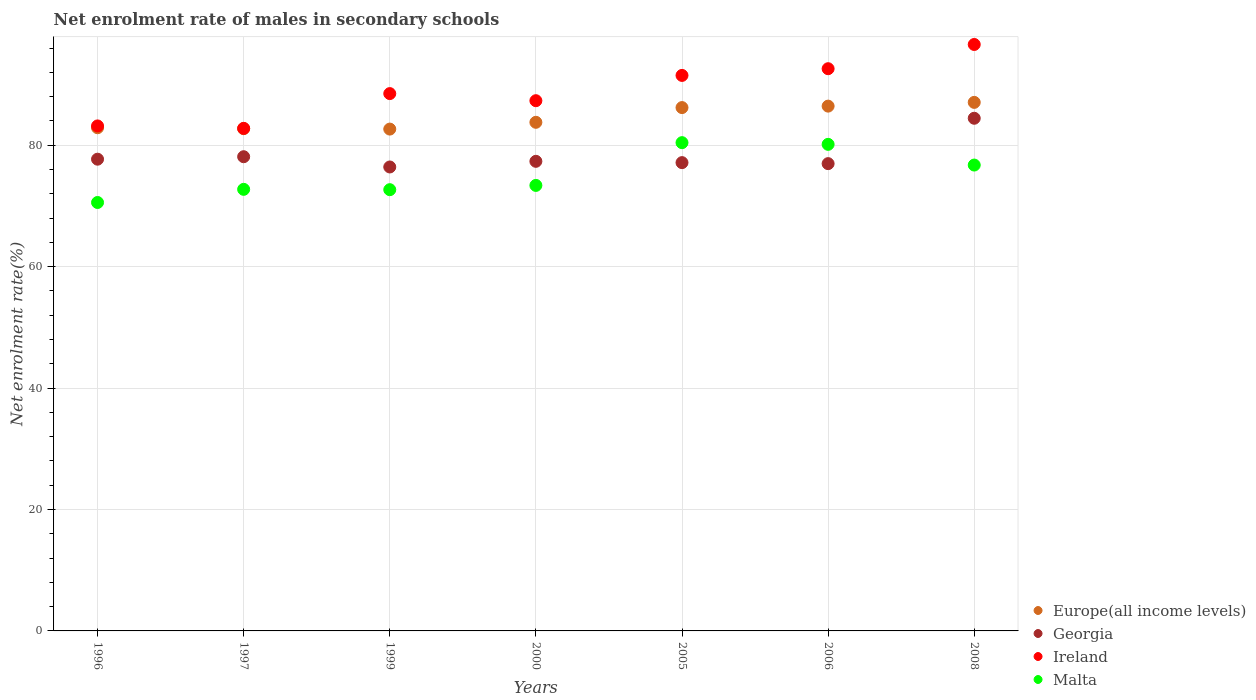Is the number of dotlines equal to the number of legend labels?
Offer a terse response. Yes. What is the net enrolment rate of males in secondary schools in Malta in 2008?
Your answer should be compact. 76.73. Across all years, what is the maximum net enrolment rate of males in secondary schools in Malta?
Provide a succinct answer. 80.41. Across all years, what is the minimum net enrolment rate of males in secondary schools in Europe(all income levels)?
Provide a short and direct response. 82.65. In which year was the net enrolment rate of males in secondary schools in Malta minimum?
Give a very brief answer. 1996. What is the total net enrolment rate of males in secondary schools in Georgia in the graph?
Keep it short and to the point. 548.06. What is the difference between the net enrolment rate of males in secondary schools in Europe(all income levels) in 2005 and that in 2008?
Keep it short and to the point. -0.86. What is the difference between the net enrolment rate of males in secondary schools in Ireland in 1996 and the net enrolment rate of males in secondary schools in Malta in 2008?
Give a very brief answer. 6.44. What is the average net enrolment rate of males in secondary schools in Europe(all income levels) per year?
Provide a succinct answer. 84.53. In the year 1999, what is the difference between the net enrolment rate of males in secondary schools in Ireland and net enrolment rate of males in secondary schools in Malta?
Provide a short and direct response. 15.82. What is the ratio of the net enrolment rate of males in secondary schools in Malta in 1997 to that in 2000?
Keep it short and to the point. 0.99. What is the difference between the highest and the second highest net enrolment rate of males in secondary schools in Ireland?
Your answer should be compact. 3.99. What is the difference between the highest and the lowest net enrolment rate of males in secondary schools in Malta?
Provide a succinct answer. 9.85. In how many years, is the net enrolment rate of males in secondary schools in Malta greater than the average net enrolment rate of males in secondary schools in Malta taken over all years?
Provide a short and direct response. 3. Is the sum of the net enrolment rate of males in secondary schools in Ireland in 1996 and 2008 greater than the maximum net enrolment rate of males in secondary schools in Europe(all income levels) across all years?
Give a very brief answer. Yes. Is it the case that in every year, the sum of the net enrolment rate of males in secondary schools in Georgia and net enrolment rate of males in secondary schools in Ireland  is greater than the sum of net enrolment rate of males in secondary schools in Europe(all income levels) and net enrolment rate of males in secondary schools in Malta?
Make the answer very short. Yes. Does the net enrolment rate of males in secondary schools in Georgia monotonically increase over the years?
Give a very brief answer. No. Is the net enrolment rate of males in secondary schools in Georgia strictly greater than the net enrolment rate of males in secondary schools in Ireland over the years?
Provide a succinct answer. No. Is the net enrolment rate of males in secondary schools in Georgia strictly less than the net enrolment rate of males in secondary schools in Malta over the years?
Your answer should be compact. No. Does the graph contain any zero values?
Your answer should be very brief. No. Where does the legend appear in the graph?
Provide a succinct answer. Bottom right. How are the legend labels stacked?
Provide a short and direct response. Vertical. What is the title of the graph?
Give a very brief answer. Net enrolment rate of males in secondary schools. Does "High income: OECD" appear as one of the legend labels in the graph?
Provide a succinct answer. No. What is the label or title of the X-axis?
Give a very brief answer. Years. What is the label or title of the Y-axis?
Provide a short and direct response. Net enrolment rate(%). What is the Net enrolment rate(%) of Europe(all income levels) in 1996?
Make the answer very short. 82.87. What is the Net enrolment rate(%) in Georgia in 1996?
Make the answer very short. 77.69. What is the Net enrolment rate(%) of Ireland in 1996?
Give a very brief answer. 83.17. What is the Net enrolment rate(%) of Malta in 1996?
Your answer should be compact. 70.56. What is the Net enrolment rate(%) of Europe(all income levels) in 1997?
Provide a short and direct response. 82.72. What is the Net enrolment rate(%) in Georgia in 1997?
Offer a terse response. 78.1. What is the Net enrolment rate(%) of Ireland in 1997?
Provide a succinct answer. 82.77. What is the Net enrolment rate(%) of Malta in 1997?
Your answer should be very brief. 72.73. What is the Net enrolment rate(%) in Europe(all income levels) in 1999?
Your answer should be very brief. 82.65. What is the Net enrolment rate(%) of Georgia in 1999?
Provide a succinct answer. 76.41. What is the Net enrolment rate(%) of Ireland in 1999?
Offer a terse response. 88.5. What is the Net enrolment rate(%) in Malta in 1999?
Offer a very short reply. 72.67. What is the Net enrolment rate(%) in Europe(all income levels) in 2000?
Offer a terse response. 83.77. What is the Net enrolment rate(%) in Georgia in 2000?
Make the answer very short. 77.34. What is the Net enrolment rate(%) in Ireland in 2000?
Provide a succinct answer. 87.33. What is the Net enrolment rate(%) of Malta in 2000?
Keep it short and to the point. 73.37. What is the Net enrolment rate(%) of Europe(all income levels) in 2005?
Keep it short and to the point. 86.19. What is the Net enrolment rate(%) in Georgia in 2005?
Your response must be concise. 77.13. What is the Net enrolment rate(%) in Ireland in 2005?
Offer a very short reply. 91.49. What is the Net enrolment rate(%) in Malta in 2005?
Give a very brief answer. 80.41. What is the Net enrolment rate(%) in Europe(all income levels) in 2006?
Keep it short and to the point. 86.43. What is the Net enrolment rate(%) of Georgia in 2006?
Keep it short and to the point. 76.96. What is the Net enrolment rate(%) of Ireland in 2006?
Ensure brevity in your answer.  92.59. What is the Net enrolment rate(%) of Malta in 2006?
Your answer should be compact. 80.14. What is the Net enrolment rate(%) in Europe(all income levels) in 2008?
Keep it short and to the point. 87.05. What is the Net enrolment rate(%) of Georgia in 2008?
Your answer should be compact. 84.43. What is the Net enrolment rate(%) in Ireland in 2008?
Make the answer very short. 96.59. What is the Net enrolment rate(%) in Malta in 2008?
Provide a succinct answer. 76.73. Across all years, what is the maximum Net enrolment rate(%) of Europe(all income levels)?
Ensure brevity in your answer.  87.05. Across all years, what is the maximum Net enrolment rate(%) in Georgia?
Your answer should be very brief. 84.43. Across all years, what is the maximum Net enrolment rate(%) in Ireland?
Ensure brevity in your answer.  96.59. Across all years, what is the maximum Net enrolment rate(%) in Malta?
Your answer should be compact. 80.41. Across all years, what is the minimum Net enrolment rate(%) of Europe(all income levels)?
Ensure brevity in your answer.  82.65. Across all years, what is the minimum Net enrolment rate(%) of Georgia?
Make the answer very short. 76.41. Across all years, what is the minimum Net enrolment rate(%) of Ireland?
Offer a terse response. 82.77. Across all years, what is the minimum Net enrolment rate(%) of Malta?
Your response must be concise. 70.56. What is the total Net enrolment rate(%) of Europe(all income levels) in the graph?
Give a very brief answer. 591.68. What is the total Net enrolment rate(%) in Georgia in the graph?
Make the answer very short. 548.06. What is the total Net enrolment rate(%) of Ireland in the graph?
Your answer should be very brief. 622.43. What is the total Net enrolment rate(%) of Malta in the graph?
Your response must be concise. 526.61. What is the difference between the Net enrolment rate(%) of Europe(all income levels) in 1996 and that in 1997?
Offer a terse response. 0.15. What is the difference between the Net enrolment rate(%) of Georgia in 1996 and that in 1997?
Your answer should be very brief. -0.41. What is the difference between the Net enrolment rate(%) of Ireland in 1996 and that in 1997?
Offer a terse response. 0.4. What is the difference between the Net enrolment rate(%) of Malta in 1996 and that in 1997?
Your answer should be very brief. -2.17. What is the difference between the Net enrolment rate(%) in Europe(all income levels) in 1996 and that in 1999?
Your answer should be very brief. 0.22. What is the difference between the Net enrolment rate(%) in Georgia in 1996 and that in 1999?
Offer a very short reply. 1.28. What is the difference between the Net enrolment rate(%) in Ireland in 1996 and that in 1999?
Make the answer very short. -5.33. What is the difference between the Net enrolment rate(%) of Malta in 1996 and that in 1999?
Make the answer very short. -2.11. What is the difference between the Net enrolment rate(%) of Europe(all income levels) in 1996 and that in 2000?
Your response must be concise. -0.9. What is the difference between the Net enrolment rate(%) of Georgia in 1996 and that in 2000?
Keep it short and to the point. 0.35. What is the difference between the Net enrolment rate(%) in Ireland in 1996 and that in 2000?
Provide a succinct answer. -4.16. What is the difference between the Net enrolment rate(%) in Malta in 1996 and that in 2000?
Give a very brief answer. -2.81. What is the difference between the Net enrolment rate(%) in Europe(all income levels) in 1996 and that in 2005?
Your answer should be compact. -3.32. What is the difference between the Net enrolment rate(%) in Georgia in 1996 and that in 2005?
Your answer should be very brief. 0.57. What is the difference between the Net enrolment rate(%) of Ireland in 1996 and that in 2005?
Offer a terse response. -8.32. What is the difference between the Net enrolment rate(%) in Malta in 1996 and that in 2005?
Make the answer very short. -9.85. What is the difference between the Net enrolment rate(%) in Europe(all income levels) in 1996 and that in 2006?
Provide a short and direct response. -3.56. What is the difference between the Net enrolment rate(%) of Georgia in 1996 and that in 2006?
Keep it short and to the point. 0.73. What is the difference between the Net enrolment rate(%) in Ireland in 1996 and that in 2006?
Offer a very short reply. -9.42. What is the difference between the Net enrolment rate(%) in Malta in 1996 and that in 2006?
Ensure brevity in your answer.  -9.58. What is the difference between the Net enrolment rate(%) of Europe(all income levels) in 1996 and that in 2008?
Your response must be concise. -4.18. What is the difference between the Net enrolment rate(%) of Georgia in 1996 and that in 2008?
Keep it short and to the point. -6.74. What is the difference between the Net enrolment rate(%) in Ireland in 1996 and that in 2008?
Your answer should be very brief. -13.42. What is the difference between the Net enrolment rate(%) of Malta in 1996 and that in 2008?
Keep it short and to the point. -6.17. What is the difference between the Net enrolment rate(%) of Europe(all income levels) in 1997 and that in 1999?
Give a very brief answer. 0.07. What is the difference between the Net enrolment rate(%) in Georgia in 1997 and that in 1999?
Your answer should be very brief. 1.69. What is the difference between the Net enrolment rate(%) of Ireland in 1997 and that in 1999?
Offer a terse response. -5.72. What is the difference between the Net enrolment rate(%) in Malta in 1997 and that in 1999?
Keep it short and to the point. 0.06. What is the difference between the Net enrolment rate(%) of Europe(all income levels) in 1997 and that in 2000?
Ensure brevity in your answer.  -1.05. What is the difference between the Net enrolment rate(%) of Georgia in 1997 and that in 2000?
Make the answer very short. 0.76. What is the difference between the Net enrolment rate(%) of Ireland in 1997 and that in 2000?
Ensure brevity in your answer.  -4.56. What is the difference between the Net enrolment rate(%) in Malta in 1997 and that in 2000?
Your response must be concise. -0.65. What is the difference between the Net enrolment rate(%) of Europe(all income levels) in 1997 and that in 2005?
Ensure brevity in your answer.  -3.47. What is the difference between the Net enrolment rate(%) of Georgia in 1997 and that in 2005?
Provide a succinct answer. 0.97. What is the difference between the Net enrolment rate(%) of Ireland in 1997 and that in 2005?
Provide a short and direct response. -8.72. What is the difference between the Net enrolment rate(%) of Malta in 1997 and that in 2005?
Your answer should be very brief. -7.69. What is the difference between the Net enrolment rate(%) in Europe(all income levels) in 1997 and that in 2006?
Offer a very short reply. -3.71. What is the difference between the Net enrolment rate(%) in Georgia in 1997 and that in 2006?
Provide a short and direct response. 1.14. What is the difference between the Net enrolment rate(%) in Ireland in 1997 and that in 2006?
Keep it short and to the point. -9.82. What is the difference between the Net enrolment rate(%) in Malta in 1997 and that in 2006?
Provide a short and direct response. -7.41. What is the difference between the Net enrolment rate(%) of Europe(all income levels) in 1997 and that in 2008?
Make the answer very short. -4.33. What is the difference between the Net enrolment rate(%) in Georgia in 1997 and that in 2008?
Your response must be concise. -6.33. What is the difference between the Net enrolment rate(%) of Ireland in 1997 and that in 2008?
Offer a terse response. -13.81. What is the difference between the Net enrolment rate(%) in Malta in 1997 and that in 2008?
Ensure brevity in your answer.  -4. What is the difference between the Net enrolment rate(%) in Europe(all income levels) in 1999 and that in 2000?
Offer a terse response. -1.12. What is the difference between the Net enrolment rate(%) of Georgia in 1999 and that in 2000?
Provide a short and direct response. -0.93. What is the difference between the Net enrolment rate(%) of Ireland in 1999 and that in 2000?
Give a very brief answer. 1.17. What is the difference between the Net enrolment rate(%) in Malta in 1999 and that in 2000?
Your response must be concise. -0.7. What is the difference between the Net enrolment rate(%) in Europe(all income levels) in 1999 and that in 2005?
Provide a succinct answer. -3.54. What is the difference between the Net enrolment rate(%) of Georgia in 1999 and that in 2005?
Provide a short and direct response. -0.72. What is the difference between the Net enrolment rate(%) of Ireland in 1999 and that in 2005?
Your response must be concise. -2.99. What is the difference between the Net enrolment rate(%) of Malta in 1999 and that in 2005?
Keep it short and to the point. -7.74. What is the difference between the Net enrolment rate(%) of Europe(all income levels) in 1999 and that in 2006?
Give a very brief answer. -3.78. What is the difference between the Net enrolment rate(%) of Georgia in 1999 and that in 2006?
Offer a very short reply. -0.55. What is the difference between the Net enrolment rate(%) of Ireland in 1999 and that in 2006?
Make the answer very short. -4.1. What is the difference between the Net enrolment rate(%) of Malta in 1999 and that in 2006?
Make the answer very short. -7.47. What is the difference between the Net enrolment rate(%) of Europe(all income levels) in 1999 and that in 2008?
Offer a terse response. -4.4. What is the difference between the Net enrolment rate(%) in Georgia in 1999 and that in 2008?
Provide a short and direct response. -8.02. What is the difference between the Net enrolment rate(%) in Ireland in 1999 and that in 2008?
Your answer should be compact. -8.09. What is the difference between the Net enrolment rate(%) of Malta in 1999 and that in 2008?
Keep it short and to the point. -4.06. What is the difference between the Net enrolment rate(%) of Europe(all income levels) in 2000 and that in 2005?
Give a very brief answer. -2.42. What is the difference between the Net enrolment rate(%) in Georgia in 2000 and that in 2005?
Provide a short and direct response. 0.22. What is the difference between the Net enrolment rate(%) of Ireland in 2000 and that in 2005?
Offer a very short reply. -4.16. What is the difference between the Net enrolment rate(%) in Malta in 2000 and that in 2005?
Make the answer very short. -7.04. What is the difference between the Net enrolment rate(%) of Europe(all income levels) in 2000 and that in 2006?
Give a very brief answer. -2.67. What is the difference between the Net enrolment rate(%) of Georgia in 2000 and that in 2006?
Make the answer very short. 0.38. What is the difference between the Net enrolment rate(%) in Ireland in 2000 and that in 2006?
Give a very brief answer. -5.27. What is the difference between the Net enrolment rate(%) in Malta in 2000 and that in 2006?
Offer a terse response. -6.76. What is the difference between the Net enrolment rate(%) of Europe(all income levels) in 2000 and that in 2008?
Your response must be concise. -3.28. What is the difference between the Net enrolment rate(%) in Georgia in 2000 and that in 2008?
Ensure brevity in your answer.  -7.09. What is the difference between the Net enrolment rate(%) in Ireland in 2000 and that in 2008?
Offer a very short reply. -9.26. What is the difference between the Net enrolment rate(%) in Malta in 2000 and that in 2008?
Offer a terse response. -3.35. What is the difference between the Net enrolment rate(%) in Europe(all income levels) in 2005 and that in 2006?
Your response must be concise. -0.24. What is the difference between the Net enrolment rate(%) in Georgia in 2005 and that in 2006?
Offer a very short reply. 0.17. What is the difference between the Net enrolment rate(%) of Ireland in 2005 and that in 2006?
Provide a short and direct response. -1.11. What is the difference between the Net enrolment rate(%) in Malta in 2005 and that in 2006?
Give a very brief answer. 0.28. What is the difference between the Net enrolment rate(%) of Europe(all income levels) in 2005 and that in 2008?
Your response must be concise. -0.86. What is the difference between the Net enrolment rate(%) of Georgia in 2005 and that in 2008?
Your answer should be very brief. -7.31. What is the difference between the Net enrolment rate(%) of Ireland in 2005 and that in 2008?
Offer a terse response. -5.1. What is the difference between the Net enrolment rate(%) of Malta in 2005 and that in 2008?
Make the answer very short. 3.69. What is the difference between the Net enrolment rate(%) in Europe(all income levels) in 2006 and that in 2008?
Your answer should be compact. -0.62. What is the difference between the Net enrolment rate(%) of Georgia in 2006 and that in 2008?
Provide a short and direct response. -7.47. What is the difference between the Net enrolment rate(%) of Ireland in 2006 and that in 2008?
Offer a very short reply. -3.99. What is the difference between the Net enrolment rate(%) of Malta in 2006 and that in 2008?
Give a very brief answer. 3.41. What is the difference between the Net enrolment rate(%) of Europe(all income levels) in 1996 and the Net enrolment rate(%) of Georgia in 1997?
Your answer should be compact. 4.77. What is the difference between the Net enrolment rate(%) of Europe(all income levels) in 1996 and the Net enrolment rate(%) of Ireland in 1997?
Ensure brevity in your answer.  0.1. What is the difference between the Net enrolment rate(%) of Europe(all income levels) in 1996 and the Net enrolment rate(%) of Malta in 1997?
Provide a succinct answer. 10.14. What is the difference between the Net enrolment rate(%) of Georgia in 1996 and the Net enrolment rate(%) of Ireland in 1997?
Ensure brevity in your answer.  -5.08. What is the difference between the Net enrolment rate(%) in Georgia in 1996 and the Net enrolment rate(%) in Malta in 1997?
Keep it short and to the point. 4.97. What is the difference between the Net enrolment rate(%) in Ireland in 1996 and the Net enrolment rate(%) in Malta in 1997?
Your answer should be compact. 10.44. What is the difference between the Net enrolment rate(%) of Europe(all income levels) in 1996 and the Net enrolment rate(%) of Georgia in 1999?
Offer a terse response. 6.46. What is the difference between the Net enrolment rate(%) of Europe(all income levels) in 1996 and the Net enrolment rate(%) of Ireland in 1999?
Provide a short and direct response. -5.62. What is the difference between the Net enrolment rate(%) of Europe(all income levels) in 1996 and the Net enrolment rate(%) of Malta in 1999?
Provide a succinct answer. 10.2. What is the difference between the Net enrolment rate(%) of Georgia in 1996 and the Net enrolment rate(%) of Ireland in 1999?
Offer a very short reply. -10.8. What is the difference between the Net enrolment rate(%) of Georgia in 1996 and the Net enrolment rate(%) of Malta in 1999?
Offer a terse response. 5.02. What is the difference between the Net enrolment rate(%) of Ireland in 1996 and the Net enrolment rate(%) of Malta in 1999?
Your answer should be compact. 10.5. What is the difference between the Net enrolment rate(%) in Europe(all income levels) in 1996 and the Net enrolment rate(%) in Georgia in 2000?
Offer a terse response. 5.53. What is the difference between the Net enrolment rate(%) of Europe(all income levels) in 1996 and the Net enrolment rate(%) of Ireland in 2000?
Provide a short and direct response. -4.46. What is the difference between the Net enrolment rate(%) in Europe(all income levels) in 1996 and the Net enrolment rate(%) in Malta in 2000?
Offer a very short reply. 9.5. What is the difference between the Net enrolment rate(%) in Georgia in 1996 and the Net enrolment rate(%) in Ireland in 2000?
Ensure brevity in your answer.  -9.63. What is the difference between the Net enrolment rate(%) in Georgia in 1996 and the Net enrolment rate(%) in Malta in 2000?
Offer a terse response. 4.32. What is the difference between the Net enrolment rate(%) of Ireland in 1996 and the Net enrolment rate(%) of Malta in 2000?
Ensure brevity in your answer.  9.8. What is the difference between the Net enrolment rate(%) in Europe(all income levels) in 1996 and the Net enrolment rate(%) in Georgia in 2005?
Make the answer very short. 5.75. What is the difference between the Net enrolment rate(%) of Europe(all income levels) in 1996 and the Net enrolment rate(%) of Ireland in 2005?
Ensure brevity in your answer.  -8.62. What is the difference between the Net enrolment rate(%) of Europe(all income levels) in 1996 and the Net enrolment rate(%) of Malta in 2005?
Provide a short and direct response. 2.46. What is the difference between the Net enrolment rate(%) in Georgia in 1996 and the Net enrolment rate(%) in Ireland in 2005?
Your response must be concise. -13.8. What is the difference between the Net enrolment rate(%) in Georgia in 1996 and the Net enrolment rate(%) in Malta in 2005?
Your answer should be very brief. -2.72. What is the difference between the Net enrolment rate(%) of Ireland in 1996 and the Net enrolment rate(%) of Malta in 2005?
Make the answer very short. 2.76. What is the difference between the Net enrolment rate(%) in Europe(all income levels) in 1996 and the Net enrolment rate(%) in Georgia in 2006?
Make the answer very short. 5.91. What is the difference between the Net enrolment rate(%) of Europe(all income levels) in 1996 and the Net enrolment rate(%) of Ireland in 2006?
Provide a short and direct response. -9.72. What is the difference between the Net enrolment rate(%) of Europe(all income levels) in 1996 and the Net enrolment rate(%) of Malta in 2006?
Offer a terse response. 2.73. What is the difference between the Net enrolment rate(%) in Georgia in 1996 and the Net enrolment rate(%) in Ireland in 2006?
Provide a short and direct response. -14.9. What is the difference between the Net enrolment rate(%) in Georgia in 1996 and the Net enrolment rate(%) in Malta in 2006?
Give a very brief answer. -2.44. What is the difference between the Net enrolment rate(%) in Ireland in 1996 and the Net enrolment rate(%) in Malta in 2006?
Your answer should be very brief. 3.03. What is the difference between the Net enrolment rate(%) of Europe(all income levels) in 1996 and the Net enrolment rate(%) of Georgia in 2008?
Your response must be concise. -1.56. What is the difference between the Net enrolment rate(%) in Europe(all income levels) in 1996 and the Net enrolment rate(%) in Ireland in 2008?
Offer a very short reply. -13.71. What is the difference between the Net enrolment rate(%) in Europe(all income levels) in 1996 and the Net enrolment rate(%) in Malta in 2008?
Your answer should be compact. 6.14. What is the difference between the Net enrolment rate(%) of Georgia in 1996 and the Net enrolment rate(%) of Ireland in 2008?
Offer a terse response. -18.89. What is the difference between the Net enrolment rate(%) in Georgia in 1996 and the Net enrolment rate(%) in Malta in 2008?
Your answer should be very brief. 0.97. What is the difference between the Net enrolment rate(%) of Ireland in 1996 and the Net enrolment rate(%) of Malta in 2008?
Give a very brief answer. 6.44. What is the difference between the Net enrolment rate(%) of Europe(all income levels) in 1997 and the Net enrolment rate(%) of Georgia in 1999?
Your answer should be compact. 6.31. What is the difference between the Net enrolment rate(%) of Europe(all income levels) in 1997 and the Net enrolment rate(%) of Ireland in 1999?
Your answer should be compact. -5.78. What is the difference between the Net enrolment rate(%) in Europe(all income levels) in 1997 and the Net enrolment rate(%) in Malta in 1999?
Your answer should be compact. 10.05. What is the difference between the Net enrolment rate(%) in Georgia in 1997 and the Net enrolment rate(%) in Ireland in 1999?
Ensure brevity in your answer.  -10.4. What is the difference between the Net enrolment rate(%) of Georgia in 1997 and the Net enrolment rate(%) of Malta in 1999?
Your answer should be compact. 5.43. What is the difference between the Net enrolment rate(%) of Ireland in 1997 and the Net enrolment rate(%) of Malta in 1999?
Make the answer very short. 10.1. What is the difference between the Net enrolment rate(%) of Europe(all income levels) in 1997 and the Net enrolment rate(%) of Georgia in 2000?
Keep it short and to the point. 5.38. What is the difference between the Net enrolment rate(%) in Europe(all income levels) in 1997 and the Net enrolment rate(%) in Ireland in 2000?
Give a very brief answer. -4.61. What is the difference between the Net enrolment rate(%) of Europe(all income levels) in 1997 and the Net enrolment rate(%) of Malta in 2000?
Offer a very short reply. 9.35. What is the difference between the Net enrolment rate(%) in Georgia in 1997 and the Net enrolment rate(%) in Ireland in 2000?
Keep it short and to the point. -9.23. What is the difference between the Net enrolment rate(%) in Georgia in 1997 and the Net enrolment rate(%) in Malta in 2000?
Provide a succinct answer. 4.73. What is the difference between the Net enrolment rate(%) in Ireland in 1997 and the Net enrolment rate(%) in Malta in 2000?
Provide a short and direct response. 9.4. What is the difference between the Net enrolment rate(%) of Europe(all income levels) in 1997 and the Net enrolment rate(%) of Georgia in 2005?
Keep it short and to the point. 5.59. What is the difference between the Net enrolment rate(%) of Europe(all income levels) in 1997 and the Net enrolment rate(%) of Ireland in 2005?
Your response must be concise. -8.77. What is the difference between the Net enrolment rate(%) in Europe(all income levels) in 1997 and the Net enrolment rate(%) in Malta in 2005?
Give a very brief answer. 2.3. What is the difference between the Net enrolment rate(%) in Georgia in 1997 and the Net enrolment rate(%) in Ireland in 2005?
Your answer should be very brief. -13.39. What is the difference between the Net enrolment rate(%) of Georgia in 1997 and the Net enrolment rate(%) of Malta in 2005?
Offer a very short reply. -2.31. What is the difference between the Net enrolment rate(%) of Ireland in 1997 and the Net enrolment rate(%) of Malta in 2005?
Your response must be concise. 2.36. What is the difference between the Net enrolment rate(%) of Europe(all income levels) in 1997 and the Net enrolment rate(%) of Georgia in 2006?
Provide a short and direct response. 5.76. What is the difference between the Net enrolment rate(%) of Europe(all income levels) in 1997 and the Net enrolment rate(%) of Ireland in 2006?
Offer a terse response. -9.88. What is the difference between the Net enrolment rate(%) in Europe(all income levels) in 1997 and the Net enrolment rate(%) in Malta in 2006?
Offer a very short reply. 2.58. What is the difference between the Net enrolment rate(%) in Georgia in 1997 and the Net enrolment rate(%) in Ireland in 2006?
Your answer should be very brief. -14.5. What is the difference between the Net enrolment rate(%) in Georgia in 1997 and the Net enrolment rate(%) in Malta in 2006?
Offer a very short reply. -2.04. What is the difference between the Net enrolment rate(%) of Ireland in 1997 and the Net enrolment rate(%) of Malta in 2006?
Give a very brief answer. 2.63. What is the difference between the Net enrolment rate(%) of Europe(all income levels) in 1997 and the Net enrolment rate(%) of Georgia in 2008?
Provide a succinct answer. -1.71. What is the difference between the Net enrolment rate(%) of Europe(all income levels) in 1997 and the Net enrolment rate(%) of Ireland in 2008?
Keep it short and to the point. -13.87. What is the difference between the Net enrolment rate(%) of Europe(all income levels) in 1997 and the Net enrolment rate(%) of Malta in 2008?
Provide a succinct answer. 5.99. What is the difference between the Net enrolment rate(%) in Georgia in 1997 and the Net enrolment rate(%) in Ireland in 2008?
Provide a succinct answer. -18.49. What is the difference between the Net enrolment rate(%) in Georgia in 1997 and the Net enrolment rate(%) in Malta in 2008?
Provide a short and direct response. 1.37. What is the difference between the Net enrolment rate(%) of Ireland in 1997 and the Net enrolment rate(%) of Malta in 2008?
Your response must be concise. 6.04. What is the difference between the Net enrolment rate(%) in Europe(all income levels) in 1999 and the Net enrolment rate(%) in Georgia in 2000?
Provide a succinct answer. 5.31. What is the difference between the Net enrolment rate(%) in Europe(all income levels) in 1999 and the Net enrolment rate(%) in Ireland in 2000?
Your response must be concise. -4.68. What is the difference between the Net enrolment rate(%) of Europe(all income levels) in 1999 and the Net enrolment rate(%) of Malta in 2000?
Ensure brevity in your answer.  9.28. What is the difference between the Net enrolment rate(%) in Georgia in 1999 and the Net enrolment rate(%) in Ireland in 2000?
Offer a terse response. -10.92. What is the difference between the Net enrolment rate(%) of Georgia in 1999 and the Net enrolment rate(%) of Malta in 2000?
Your answer should be compact. 3.04. What is the difference between the Net enrolment rate(%) in Ireland in 1999 and the Net enrolment rate(%) in Malta in 2000?
Provide a succinct answer. 15.12. What is the difference between the Net enrolment rate(%) of Europe(all income levels) in 1999 and the Net enrolment rate(%) of Georgia in 2005?
Your response must be concise. 5.52. What is the difference between the Net enrolment rate(%) of Europe(all income levels) in 1999 and the Net enrolment rate(%) of Ireland in 2005?
Your response must be concise. -8.84. What is the difference between the Net enrolment rate(%) of Europe(all income levels) in 1999 and the Net enrolment rate(%) of Malta in 2005?
Your answer should be very brief. 2.23. What is the difference between the Net enrolment rate(%) in Georgia in 1999 and the Net enrolment rate(%) in Ireland in 2005?
Your answer should be compact. -15.08. What is the difference between the Net enrolment rate(%) in Georgia in 1999 and the Net enrolment rate(%) in Malta in 2005?
Provide a succinct answer. -4.01. What is the difference between the Net enrolment rate(%) in Ireland in 1999 and the Net enrolment rate(%) in Malta in 2005?
Provide a succinct answer. 8.08. What is the difference between the Net enrolment rate(%) of Europe(all income levels) in 1999 and the Net enrolment rate(%) of Georgia in 2006?
Give a very brief answer. 5.69. What is the difference between the Net enrolment rate(%) in Europe(all income levels) in 1999 and the Net enrolment rate(%) in Ireland in 2006?
Provide a short and direct response. -9.95. What is the difference between the Net enrolment rate(%) of Europe(all income levels) in 1999 and the Net enrolment rate(%) of Malta in 2006?
Give a very brief answer. 2.51. What is the difference between the Net enrolment rate(%) of Georgia in 1999 and the Net enrolment rate(%) of Ireland in 2006?
Provide a succinct answer. -16.19. What is the difference between the Net enrolment rate(%) of Georgia in 1999 and the Net enrolment rate(%) of Malta in 2006?
Make the answer very short. -3.73. What is the difference between the Net enrolment rate(%) of Ireland in 1999 and the Net enrolment rate(%) of Malta in 2006?
Provide a short and direct response. 8.36. What is the difference between the Net enrolment rate(%) of Europe(all income levels) in 1999 and the Net enrolment rate(%) of Georgia in 2008?
Provide a succinct answer. -1.78. What is the difference between the Net enrolment rate(%) of Europe(all income levels) in 1999 and the Net enrolment rate(%) of Ireland in 2008?
Your answer should be very brief. -13.94. What is the difference between the Net enrolment rate(%) of Europe(all income levels) in 1999 and the Net enrolment rate(%) of Malta in 2008?
Make the answer very short. 5.92. What is the difference between the Net enrolment rate(%) in Georgia in 1999 and the Net enrolment rate(%) in Ireland in 2008?
Provide a short and direct response. -20.18. What is the difference between the Net enrolment rate(%) of Georgia in 1999 and the Net enrolment rate(%) of Malta in 2008?
Make the answer very short. -0.32. What is the difference between the Net enrolment rate(%) in Ireland in 1999 and the Net enrolment rate(%) in Malta in 2008?
Offer a terse response. 11.77. What is the difference between the Net enrolment rate(%) in Europe(all income levels) in 2000 and the Net enrolment rate(%) in Georgia in 2005?
Your response must be concise. 6.64. What is the difference between the Net enrolment rate(%) in Europe(all income levels) in 2000 and the Net enrolment rate(%) in Ireland in 2005?
Offer a very short reply. -7.72. What is the difference between the Net enrolment rate(%) in Europe(all income levels) in 2000 and the Net enrolment rate(%) in Malta in 2005?
Your answer should be very brief. 3.35. What is the difference between the Net enrolment rate(%) in Georgia in 2000 and the Net enrolment rate(%) in Ireland in 2005?
Provide a short and direct response. -14.15. What is the difference between the Net enrolment rate(%) of Georgia in 2000 and the Net enrolment rate(%) of Malta in 2005?
Make the answer very short. -3.07. What is the difference between the Net enrolment rate(%) of Ireland in 2000 and the Net enrolment rate(%) of Malta in 2005?
Make the answer very short. 6.91. What is the difference between the Net enrolment rate(%) in Europe(all income levels) in 2000 and the Net enrolment rate(%) in Georgia in 2006?
Your answer should be very brief. 6.81. What is the difference between the Net enrolment rate(%) in Europe(all income levels) in 2000 and the Net enrolment rate(%) in Ireland in 2006?
Make the answer very short. -8.83. What is the difference between the Net enrolment rate(%) in Europe(all income levels) in 2000 and the Net enrolment rate(%) in Malta in 2006?
Your answer should be very brief. 3.63. What is the difference between the Net enrolment rate(%) of Georgia in 2000 and the Net enrolment rate(%) of Ireland in 2006?
Your response must be concise. -15.25. What is the difference between the Net enrolment rate(%) of Georgia in 2000 and the Net enrolment rate(%) of Malta in 2006?
Give a very brief answer. -2.8. What is the difference between the Net enrolment rate(%) in Ireland in 2000 and the Net enrolment rate(%) in Malta in 2006?
Ensure brevity in your answer.  7.19. What is the difference between the Net enrolment rate(%) of Europe(all income levels) in 2000 and the Net enrolment rate(%) of Georgia in 2008?
Your answer should be very brief. -0.67. What is the difference between the Net enrolment rate(%) of Europe(all income levels) in 2000 and the Net enrolment rate(%) of Ireland in 2008?
Keep it short and to the point. -12.82. What is the difference between the Net enrolment rate(%) of Europe(all income levels) in 2000 and the Net enrolment rate(%) of Malta in 2008?
Offer a terse response. 7.04. What is the difference between the Net enrolment rate(%) in Georgia in 2000 and the Net enrolment rate(%) in Ireland in 2008?
Provide a short and direct response. -19.24. What is the difference between the Net enrolment rate(%) in Georgia in 2000 and the Net enrolment rate(%) in Malta in 2008?
Make the answer very short. 0.61. What is the difference between the Net enrolment rate(%) of Ireland in 2000 and the Net enrolment rate(%) of Malta in 2008?
Your answer should be compact. 10.6. What is the difference between the Net enrolment rate(%) of Europe(all income levels) in 2005 and the Net enrolment rate(%) of Georgia in 2006?
Your response must be concise. 9.23. What is the difference between the Net enrolment rate(%) of Europe(all income levels) in 2005 and the Net enrolment rate(%) of Ireland in 2006?
Offer a very short reply. -6.4. What is the difference between the Net enrolment rate(%) in Europe(all income levels) in 2005 and the Net enrolment rate(%) in Malta in 2006?
Give a very brief answer. 6.05. What is the difference between the Net enrolment rate(%) of Georgia in 2005 and the Net enrolment rate(%) of Ireland in 2006?
Provide a short and direct response. -15.47. What is the difference between the Net enrolment rate(%) in Georgia in 2005 and the Net enrolment rate(%) in Malta in 2006?
Your answer should be compact. -3.01. What is the difference between the Net enrolment rate(%) of Ireland in 2005 and the Net enrolment rate(%) of Malta in 2006?
Keep it short and to the point. 11.35. What is the difference between the Net enrolment rate(%) of Europe(all income levels) in 2005 and the Net enrolment rate(%) of Georgia in 2008?
Your response must be concise. 1.76. What is the difference between the Net enrolment rate(%) in Europe(all income levels) in 2005 and the Net enrolment rate(%) in Ireland in 2008?
Your response must be concise. -10.39. What is the difference between the Net enrolment rate(%) of Europe(all income levels) in 2005 and the Net enrolment rate(%) of Malta in 2008?
Provide a short and direct response. 9.46. What is the difference between the Net enrolment rate(%) of Georgia in 2005 and the Net enrolment rate(%) of Ireland in 2008?
Offer a very short reply. -19.46. What is the difference between the Net enrolment rate(%) in Georgia in 2005 and the Net enrolment rate(%) in Malta in 2008?
Your answer should be very brief. 0.4. What is the difference between the Net enrolment rate(%) in Ireland in 2005 and the Net enrolment rate(%) in Malta in 2008?
Keep it short and to the point. 14.76. What is the difference between the Net enrolment rate(%) of Europe(all income levels) in 2006 and the Net enrolment rate(%) of Georgia in 2008?
Offer a very short reply. 2. What is the difference between the Net enrolment rate(%) in Europe(all income levels) in 2006 and the Net enrolment rate(%) in Ireland in 2008?
Your answer should be very brief. -10.15. What is the difference between the Net enrolment rate(%) in Europe(all income levels) in 2006 and the Net enrolment rate(%) in Malta in 2008?
Your response must be concise. 9.71. What is the difference between the Net enrolment rate(%) in Georgia in 2006 and the Net enrolment rate(%) in Ireland in 2008?
Ensure brevity in your answer.  -19.63. What is the difference between the Net enrolment rate(%) of Georgia in 2006 and the Net enrolment rate(%) of Malta in 2008?
Offer a terse response. 0.23. What is the difference between the Net enrolment rate(%) of Ireland in 2006 and the Net enrolment rate(%) of Malta in 2008?
Ensure brevity in your answer.  15.87. What is the average Net enrolment rate(%) of Europe(all income levels) per year?
Your answer should be very brief. 84.53. What is the average Net enrolment rate(%) in Georgia per year?
Make the answer very short. 78.29. What is the average Net enrolment rate(%) in Ireland per year?
Ensure brevity in your answer.  88.92. What is the average Net enrolment rate(%) in Malta per year?
Keep it short and to the point. 75.23. In the year 1996, what is the difference between the Net enrolment rate(%) in Europe(all income levels) and Net enrolment rate(%) in Georgia?
Provide a succinct answer. 5.18. In the year 1996, what is the difference between the Net enrolment rate(%) of Europe(all income levels) and Net enrolment rate(%) of Ireland?
Your answer should be very brief. -0.3. In the year 1996, what is the difference between the Net enrolment rate(%) of Europe(all income levels) and Net enrolment rate(%) of Malta?
Offer a very short reply. 12.31. In the year 1996, what is the difference between the Net enrolment rate(%) in Georgia and Net enrolment rate(%) in Ireland?
Offer a terse response. -5.48. In the year 1996, what is the difference between the Net enrolment rate(%) of Georgia and Net enrolment rate(%) of Malta?
Offer a very short reply. 7.13. In the year 1996, what is the difference between the Net enrolment rate(%) in Ireland and Net enrolment rate(%) in Malta?
Offer a terse response. 12.61. In the year 1997, what is the difference between the Net enrolment rate(%) in Europe(all income levels) and Net enrolment rate(%) in Georgia?
Provide a short and direct response. 4.62. In the year 1997, what is the difference between the Net enrolment rate(%) in Europe(all income levels) and Net enrolment rate(%) in Ireland?
Provide a short and direct response. -0.05. In the year 1997, what is the difference between the Net enrolment rate(%) of Europe(all income levels) and Net enrolment rate(%) of Malta?
Keep it short and to the point. 9.99. In the year 1997, what is the difference between the Net enrolment rate(%) in Georgia and Net enrolment rate(%) in Ireland?
Provide a short and direct response. -4.67. In the year 1997, what is the difference between the Net enrolment rate(%) of Georgia and Net enrolment rate(%) of Malta?
Your answer should be compact. 5.37. In the year 1997, what is the difference between the Net enrolment rate(%) of Ireland and Net enrolment rate(%) of Malta?
Make the answer very short. 10.04. In the year 1999, what is the difference between the Net enrolment rate(%) of Europe(all income levels) and Net enrolment rate(%) of Georgia?
Keep it short and to the point. 6.24. In the year 1999, what is the difference between the Net enrolment rate(%) of Europe(all income levels) and Net enrolment rate(%) of Ireland?
Give a very brief answer. -5.85. In the year 1999, what is the difference between the Net enrolment rate(%) of Europe(all income levels) and Net enrolment rate(%) of Malta?
Your answer should be compact. 9.98. In the year 1999, what is the difference between the Net enrolment rate(%) of Georgia and Net enrolment rate(%) of Ireland?
Keep it short and to the point. -12.09. In the year 1999, what is the difference between the Net enrolment rate(%) in Georgia and Net enrolment rate(%) in Malta?
Ensure brevity in your answer.  3.74. In the year 1999, what is the difference between the Net enrolment rate(%) in Ireland and Net enrolment rate(%) in Malta?
Provide a succinct answer. 15.82. In the year 2000, what is the difference between the Net enrolment rate(%) of Europe(all income levels) and Net enrolment rate(%) of Georgia?
Offer a very short reply. 6.43. In the year 2000, what is the difference between the Net enrolment rate(%) of Europe(all income levels) and Net enrolment rate(%) of Ireland?
Offer a very short reply. -3.56. In the year 2000, what is the difference between the Net enrolment rate(%) in Europe(all income levels) and Net enrolment rate(%) in Malta?
Your answer should be compact. 10.39. In the year 2000, what is the difference between the Net enrolment rate(%) of Georgia and Net enrolment rate(%) of Ireland?
Make the answer very short. -9.99. In the year 2000, what is the difference between the Net enrolment rate(%) in Georgia and Net enrolment rate(%) in Malta?
Your answer should be very brief. 3.97. In the year 2000, what is the difference between the Net enrolment rate(%) in Ireland and Net enrolment rate(%) in Malta?
Provide a succinct answer. 13.95. In the year 2005, what is the difference between the Net enrolment rate(%) of Europe(all income levels) and Net enrolment rate(%) of Georgia?
Give a very brief answer. 9.07. In the year 2005, what is the difference between the Net enrolment rate(%) in Europe(all income levels) and Net enrolment rate(%) in Ireland?
Ensure brevity in your answer.  -5.3. In the year 2005, what is the difference between the Net enrolment rate(%) in Europe(all income levels) and Net enrolment rate(%) in Malta?
Your answer should be very brief. 5.78. In the year 2005, what is the difference between the Net enrolment rate(%) of Georgia and Net enrolment rate(%) of Ireland?
Keep it short and to the point. -14.36. In the year 2005, what is the difference between the Net enrolment rate(%) in Georgia and Net enrolment rate(%) in Malta?
Your response must be concise. -3.29. In the year 2005, what is the difference between the Net enrolment rate(%) in Ireland and Net enrolment rate(%) in Malta?
Your response must be concise. 11.07. In the year 2006, what is the difference between the Net enrolment rate(%) of Europe(all income levels) and Net enrolment rate(%) of Georgia?
Provide a short and direct response. 9.47. In the year 2006, what is the difference between the Net enrolment rate(%) of Europe(all income levels) and Net enrolment rate(%) of Ireland?
Your answer should be very brief. -6.16. In the year 2006, what is the difference between the Net enrolment rate(%) in Europe(all income levels) and Net enrolment rate(%) in Malta?
Offer a very short reply. 6.3. In the year 2006, what is the difference between the Net enrolment rate(%) of Georgia and Net enrolment rate(%) of Ireland?
Your response must be concise. -15.63. In the year 2006, what is the difference between the Net enrolment rate(%) of Georgia and Net enrolment rate(%) of Malta?
Your answer should be compact. -3.18. In the year 2006, what is the difference between the Net enrolment rate(%) of Ireland and Net enrolment rate(%) of Malta?
Offer a very short reply. 12.46. In the year 2008, what is the difference between the Net enrolment rate(%) of Europe(all income levels) and Net enrolment rate(%) of Georgia?
Your response must be concise. 2.61. In the year 2008, what is the difference between the Net enrolment rate(%) of Europe(all income levels) and Net enrolment rate(%) of Ireland?
Give a very brief answer. -9.54. In the year 2008, what is the difference between the Net enrolment rate(%) of Europe(all income levels) and Net enrolment rate(%) of Malta?
Offer a terse response. 10.32. In the year 2008, what is the difference between the Net enrolment rate(%) in Georgia and Net enrolment rate(%) in Ireland?
Offer a very short reply. -12.15. In the year 2008, what is the difference between the Net enrolment rate(%) in Georgia and Net enrolment rate(%) in Malta?
Offer a terse response. 7.71. In the year 2008, what is the difference between the Net enrolment rate(%) in Ireland and Net enrolment rate(%) in Malta?
Ensure brevity in your answer.  19.86. What is the ratio of the Net enrolment rate(%) of Georgia in 1996 to that in 1997?
Your answer should be compact. 0.99. What is the ratio of the Net enrolment rate(%) of Ireland in 1996 to that in 1997?
Offer a terse response. 1. What is the ratio of the Net enrolment rate(%) of Malta in 1996 to that in 1997?
Make the answer very short. 0.97. What is the ratio of the Net enrolment rate(%) in Europe(all income levels) in 1996 to that in 1999?
Make the answer very short. 1. What is the ratio of the Net enrolment rate(%) of Georgia in 1996 to that in 1999?
Keep it short and to the point. 1.02. What is the ratio of the Net enrolment rate(%) in Ireland in 1996 to that in 1999?
Ensure brevity in your answer.  0.94. What is the ratio of the Net enrolment rate(%) in Europe(all income levels) in 1996 to that in 2000?
Provide a short and direct response. 0.99. What is the ratio of the Net enrolment rate(%) in Ireland in 1996 to that in 2000?
Your response must be concise. 0.95. What is the ratio of the Net enrolment rate(%) in Malta in 1996 to that in 2000?
Give a very brief answer. 0.96. What is the ratio of the Net enrolment rate(%) in Europe(all income levels) in 1996 to that in 2005?
Ensure brevity in your answer.  0.96. What is the ratio of the Net enrolment rate(%) of Georgia in 1996 to that in 2005?
Keep it short and to the point. 1.01. What is the ratio of the Net enrolment rate(%) in Malta in 1996 to that in 2005?
Offer a terse response. 0.88. What is the ratio of the Net enrolment rate(%) of Europe(all income levels) in 1996 to that in 2006?
Offer a terse response. 0.96. What is the ratio of the Net enrolment rate(%) in Georgia in 1996 to that in 2006?
Provide a succinct answer. 1.01. What is the ratio of the Net enrolment rate(%) in Ireland in 1996 to that in 2006?
Provide a succinct answer. 0.9. What is the ratio of the Net enrolment rate(%) in Malta in 1996 to that in 2006?
Ensure brevity in your answer.  0.88. What is the ratio of the Net enrolment rate(%) of Europe(all income levels) in 1996 to that in 2008?
Provide a succinct answer. 0.95. What is the ratio of the Net enrolment rate(%) in Georgia in 1996 to that in 2008?
Your response must be concise. 0.92. What is the ratio of the Net enrolment rate(%) of Ireland in 1996 to that in 2008?
Make the answer very short. 0.86. What is the ratio of the Net enrolment rate(%) of Malta in 1996 to that in 2008?
Keep it short and to the point. 0.92. What is the ratio of the Net enrolment rate(%) in Europe(all income levels) in 1997 to that in 1999?
Offer a terse response. 1. What is the ratio of the Net enrolment rate(%) in Georgia in 1997 to that in 1999?
Offer a very short reply. 1.02. What is the ratio of the Net enrolment rate(%) of Ireland in 1997 to that in 1999?
Provide a short and direct response. 0.94. What is the ratio of the Net enrolment rate(%) in Malta in 1997 to that in 1999?
Provide a short and direct response. 1. What is the ratio of the Net enrolment rate(%) in Europe(all income levels) in 1997 to that in 2000?
Provide a short and direct response. 0.99. What is the ratio of the Net enrolment rate(%) in Georgia in 1997 to that in 2000?
Provide a short and direct response. 1.01. What is the ratio of the Net enrolment rate(%) of Ireland in 1997 to that in 2000?
Offer a terse response. 0.95. What is the ratio of the Net enrolment rate(%) of Europe(all income levels) in 1997 to that in 2005?
Ensure brevity in your answer.  0.96. What is the ratio of the Net enrolment rate(%) of Georgia in 1997 to that in 2005?
Provide a succinct answer. 1.01. What is the ratio of the Net enrolment rate(%) of Ireland in 1997 to that in 2005?
Offer a very short reply. 0.9. What is the ratio of the Net enrolment rate(%) of Malta in 1997 to that in 2005?
Provide a succinct answer. 0.9. What is the ratio of the Net enrolment rate(%) of Georgia in 1997 to that in 2006?
Provide a succinct answer. 1.01. What is the ratio of the Net enrolment rate(%) of Ireland in 1997 to that in 2006?
Provide a short and direct response. 0.89. What is the ratio of the Net enrolment rate(%) in Malta in 1997 to that in 2006?
Offer a terse response. 0.91. What is the ratio of the Net enrolment rate(%) of Europe(all income levels) in 1997 to that in 2008?
Give a very brief answer. 0.95. What is the ratio of the Net enrolment rate(%) of Georgia in 1997 to that in 2008?
Offer a terse response. 0.93. What is the ratio of the Net enrolment rate(%) in Ireland in 1997 to that in 2008?
Provide a short and direct response. 0.86. What is the ratio of the Net enrolment rate(%) in Malta in 1997 to that in 2008?
Your answer should be very brief. 0.95. What is the ratio of the Net enrolment rate(%) of Europe(all income levels) in 1999 to that in 2000?
Keep it short and to the point. 0.99. What is the ratio of the Net enrolment rate(%) in Georgia in 1999 to that in 2000?
Give a very brief answer. 0.99. What is the ratio of the Net enrolment rate(%) in Ireland in 1999 to that in 2000?
Keep it short and to the point. 1.01. What is the ratio of the Net enrolment rate(%) of Malta in 1999 to that in 2000?
Make the answer very short. 0.99. What is the ratio of the Net enrolment rate(%) of Europe(all income levels) in 1999 to that in 2005?
Keep it short and to the point. 0.96. What is the ratio of the Net enrolment rate(%) in Georgia in 1999 to that in 2005?
Offer a very short reply. 0.99. What is the ratio of the Net enrolment rate(%) in Ireland in 1999 to that in 2005?
Your answer should be very brief. 0.97. What is the ratio of the Net enrolment rate(%) of Malta in 1999 to that in 2005?
Provide a succinct answer. 0.9. What is the ratio of the Net enrolment rate(%) of Europe(all income levels) in 1999 to that in 2006?
Offer a terse response. 0.96. What is the ratio of the Net enrolment rate(%) of Ireland in 1999 to that in 2006?
Provide a short and direct response. 0.96. What is the ratio of the Net enrolment rate(%) of Malta in 1999 to that in 2006?
Give a very brief answer. 0.91. What is the ratio of the Net enrolment rate(%) of Europe(all income levels) in 1999 to that in 2008?
Offer a very short reply. 0.95. What is the ratio of the Net enrolment rate(%) in Georgia in 1999 to that in 2008?
Provide a short and direct response. 0.91. What is the ratio of the Net enrolment rate(%) of Ireland in 1999 to that in 2008?
Ensure brevity in your answer.  0.92. What is the ratio of the Net enrolment rate(%) in Malta in 1999 to that in 2008?
Your answer should be compact. 0.95. What is the ratio of the Net enrolment rate(%) of Europe(all income levels) in 2000 to that in 2005?
Your answer should be compact. 0.97. What is the ratio of the Net enrolment rate(%) in Ireland in 2000 to that in 2005?
Your response must be concise. 0.95. What is the ratio of the Net enrolment rate(%) of Malta in 2000 to that in 2005?
Make the answer very short. 0.91. What is the ratio of the Net enrolment rate(%) in Europe(all income levels) in 2000 to that in 2006?
Offer a terse response. 0.97. What is the ratio of the Net enrolment rate(%) in Georgia in 2000 to that in 2006?
Give a very brief answer. 1. What is the ratio of the Net enrolment rate(%) in Ireland in 2000 to that in 2006?
Offer a terse response. 0.94. What is the ratio of the Net enrolment rate(%) of Malta in 2000 to that in 2006?
Keep it short and to the point. 0.92. What is the ratio of the Net enrolment rate(%) in Europe(all income levels) in 2000 to that in 2008?
Your response must be concise. 0.96. What is the ratio of the Net enrolment rate(%) of Georgia in 2000 to that in 2008?
Provide a short and direct response. 0.92. What is the ratio of the Net enrolment rate(%) in Ireland in 2000 to that in 2008?
Make the answer very short. 0.9. What is the ratio of the Net enrolment rate(%) in Malta in 2000 to that in 2008?
Your answer should be very brief. 0.96. What is the ratio of the Net enrolment rate(%) of Georgia in 2005 to that in 2006?
Ensure brevity in your answer.  1. What is the ratio of the Net enrolment rate(%) of Europe(all income levels) in 2005 to that in 2008?
Keep it short and to the point. 0.99. What is the ratio of the Net enrolment rate(%) in Georgia in 2005 to that in 2008?
Give a very brief answer. 0.91. What is the ratio of the Net enrolment rate(%) of Ireland in 2005 to that in 2008?
Ensure brevity in your answer.  0.95. What is the ratio of the Net enrolment rate(%) of Malta in 2005 to that in 2008?
Keep it short and to the point. 1.05. What is the ratio of the Net enrolment rate(%) in Europe(all income levels) in 2006 to that in 2008?
Offer a terse response. 0.99. What is the ratio of the Net enrolment rate(%) of Georgia in 2006 to that in 2008?
Your answer should be very brief. 0.91. What is the ratio of the Net enrolment rate(%) in Ireland in 2006 to that in 2008?
Offer a terse response. 0.96. What is the ratio of the Net enrolment rate(%) in Malta in 2006 to that in 2008?
Offer a very short reply. 1.04. What is the difference between the highest and the second highest Net enrolment rate(%) in Europe(all income levels)?
Keep it short and to the point. 0.62. What is the difference between the highest and the second highest Net enrolment rate(%) of Georgia?
Offer a very short reply. 6.33. What is the difference between the highest and the second highest Net enrolment rate(%) in Ireland?
Your answer should be very brief. 3.99. What is the difference between the highest and the second highest Net enrolment rate(%) in Malta?
Offer a terse response. 0.28. What is the difference between the highest and the lowest Net enrolment rate(%) of Europe(all income levels)?
Your answer should be compact. 4.4. What is the difference between the highest and the lowest Net enrolment rate(%) of Georgia?
Provide a succinct answer. 8.02. What is the difference between the highest and the lowest Net enrolment rate(%) in Ireland?
Keep it short and to the point. 13.81. What is the difference between the highest and the lowest Net enrolment rate(%) in Malta?
Your answer should be very brief. 9.85. 